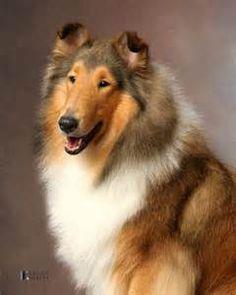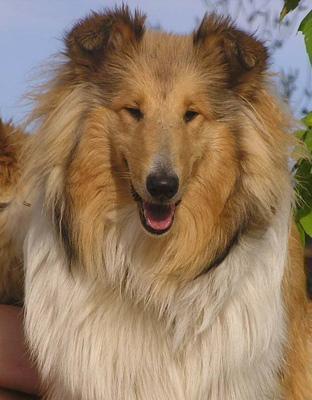The first image is the image on the left, the second image is the image on the right. Analyze the images presented: Is the assertion "A collie is pictured on an outdoor light blue background." valid? Answer yes or no. Yes. 